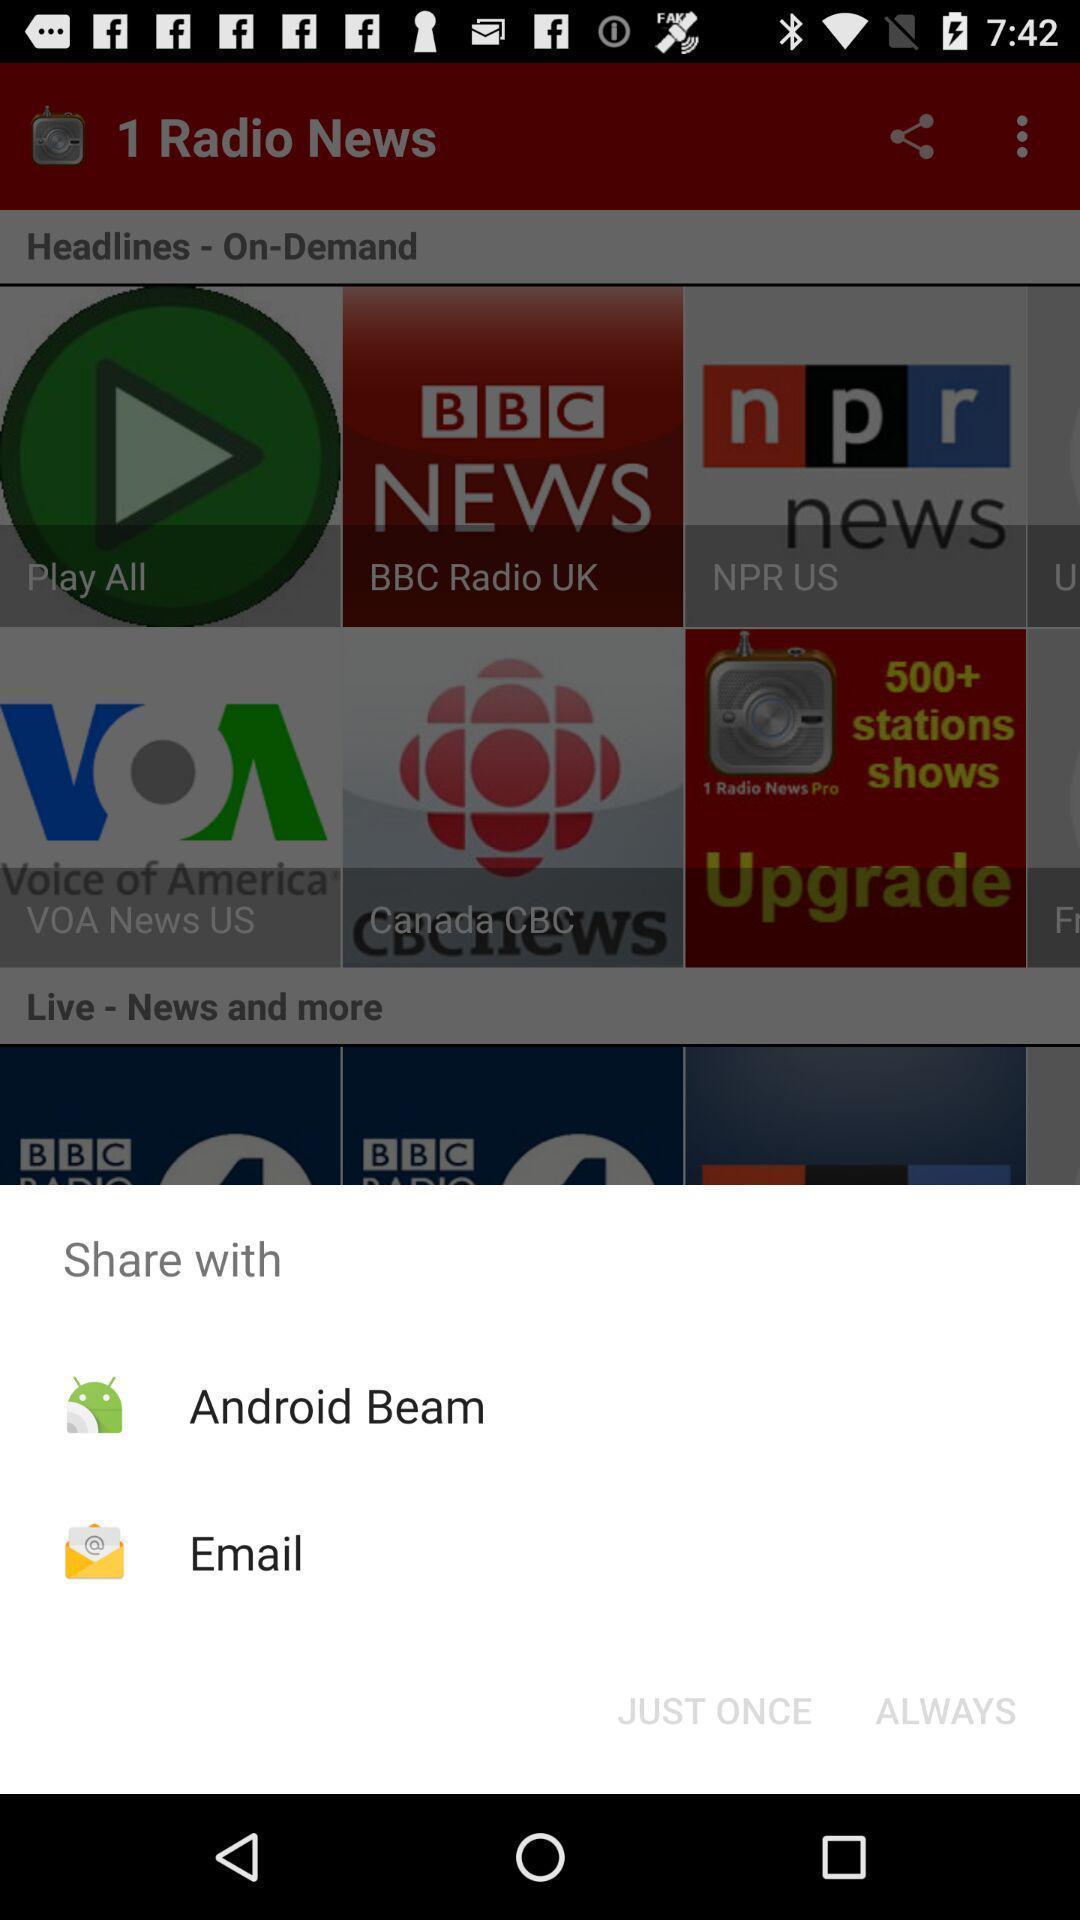Please provide a description for this image. Pop up with options to share with an application. 